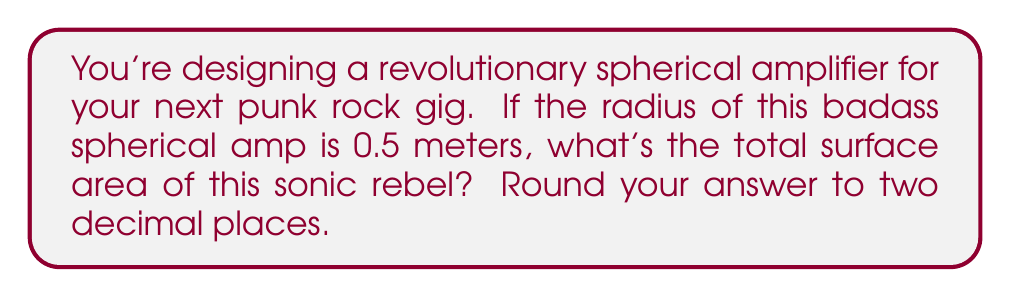Can you solve this math problem? Let's crank up the math to solve this punk rock problem:

1) The formula for the surface area of a sphere is:

   $$A = 4\pi r^2$$

   Where $A$ is the surface area and $r$ is the radius.

2) We're given that the radius is 0.5 meters. Let's plug this into our formula:

   $$A = 4\pi (0.5)^2$$

3) Let's simplify the equation:
   
   $$A = 4\pi (0.25)$$
   $$A = \pi$$

4) Now, let's calculate this value. $\pi$ is approximately 3.14159...

   $$A \approx 3.14159$$

5) Rounding to two decimal places:

   $$A \approx 3.14 \text{ m}^2$$

Thus, the surface area of your spherical amp is approximately 3.14 square meters.
Answer: $3.14 \text{ m}^2$ 